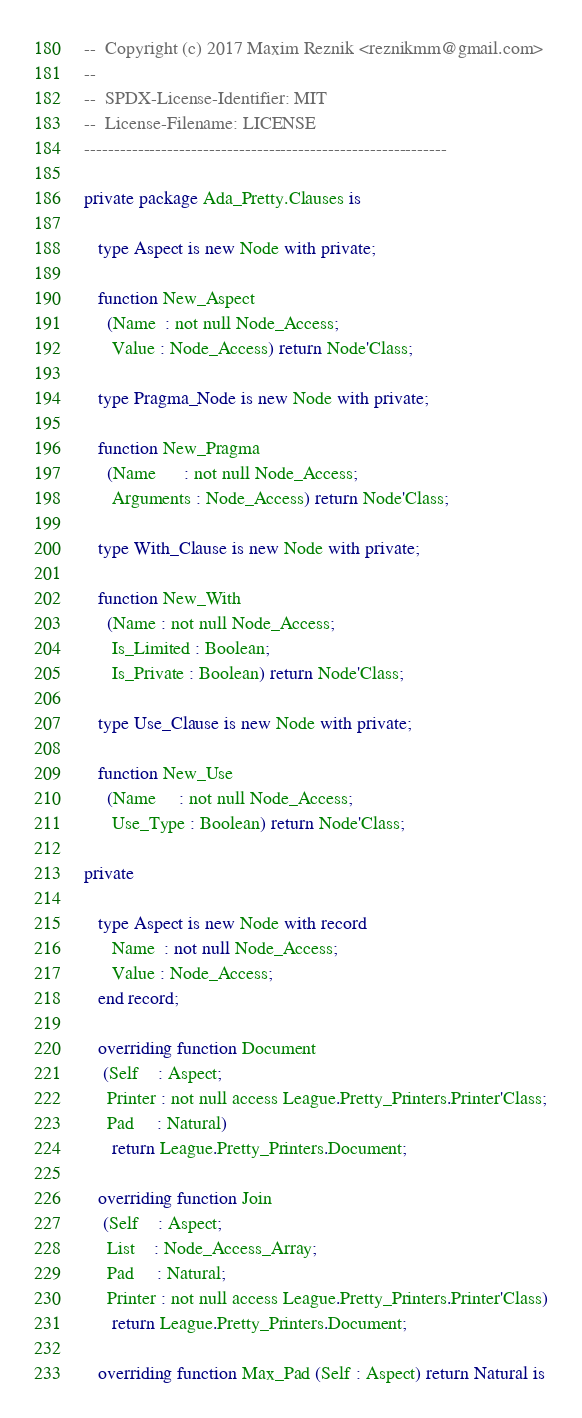Convert code to text. <code><loc_0><loc_0><loc_500><loc_500><_Ada_>--  Copyright (c) 2017 Maxim Reznik <reznikmm@gmail.com>
--
--  SPDX-License-Identifier: MIT
--  License-Filename: LICENSE
-------------------------------------------------------------

private package Ada_Pretty.Clauses is

   type Aspect is new Node with private;

   function New_Aspect
     (Name  : not null Node_Access;
      Value : Node_Access) return Node'Class;

   type Pragma_Node is new Node with private;

   function New_Pragma
     (Name      : not null Node_Access;
      Arguments : Node_Access) return Node'Class;

   type With_Clause is new Node with private;

   function New_With
     (Name : not null Node_Access;
      Is_Limited : Boolean;
      Is_Private : Boolean) return Node'Class;

   type Use_Clause is new Node with private;

   function New_Use
     (Name     : not null Node_Access;
      Use_Type : Boolean) return Node'Class;

private

   type Aspect is new Node with record
      Name  : not null Node_Access;
      Value : Node_Access;
   end record;

   overriding function Document
    (Self    : Aspect;
     Printer : not null access League.Pretty_Printers.Printer'Class;
     Pad     : Natural)
      return League.Pretty_Printers.Document;

   overriding function Join
    (Self    : Aspect;
     List    : Node_Access_Array;
     Pad     : Natural;
     Printer : not null access League.Pretty_Printers.Printer'Class)
      return League.Pretty_Printers.Document;

   overriding function Max_Pad (Self : Aspect) return Natural is</code> 